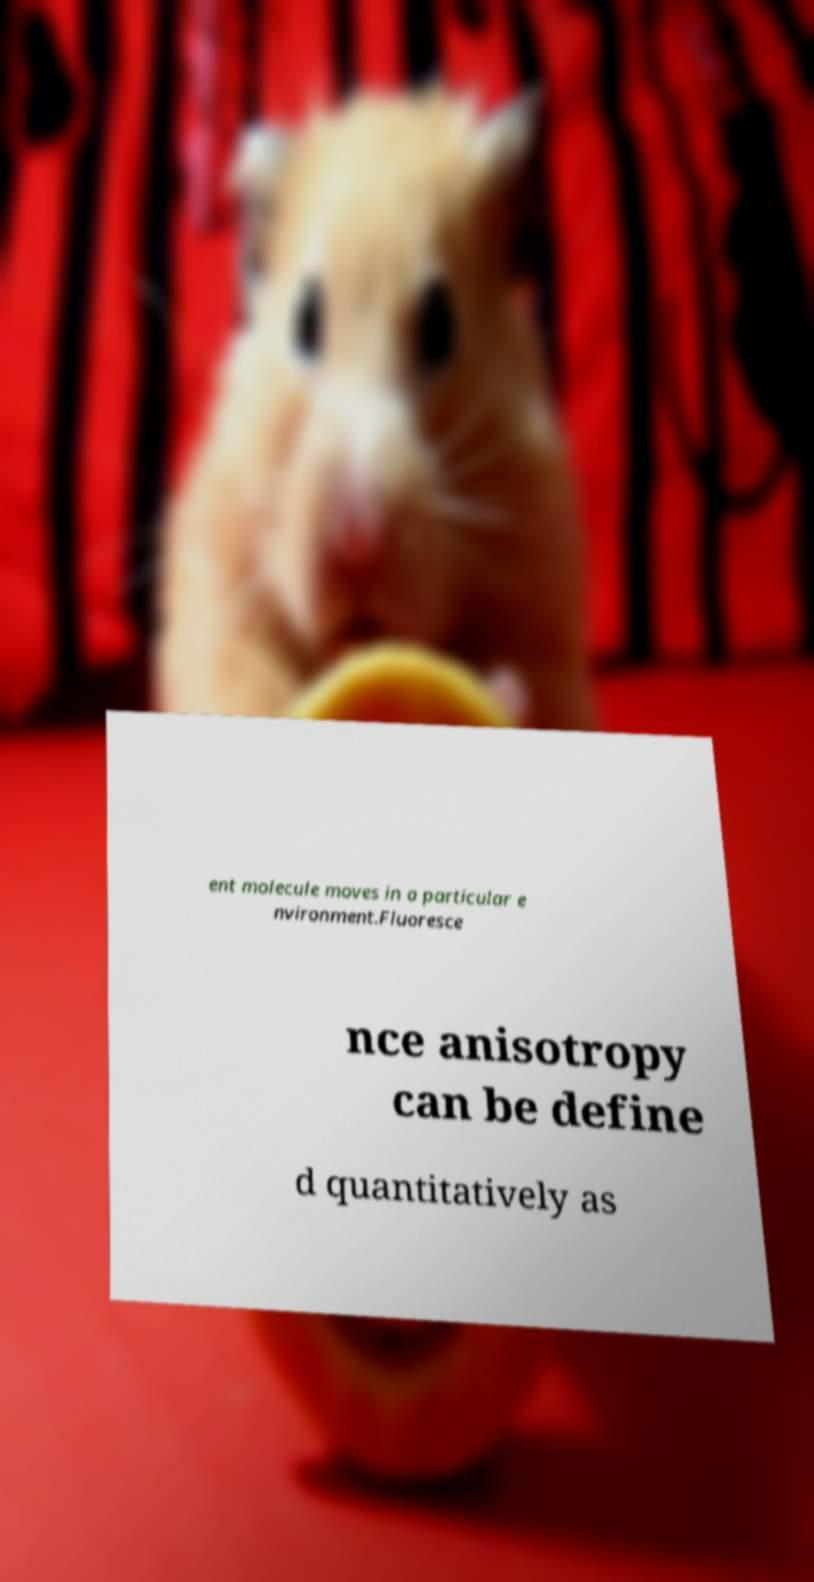Could you extract and type out the text from this image? ent molecule moves in a particular e nvironment.Fluoresce nce anisotropy can be define d quantitatively as 